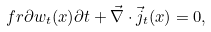Convert formula to latex. <formula><loc_0><loc_0><loc_500><loc_500>\ f r { \partial w _ { t } ( x ) } { \partial t } + \vec { \nabla } \cdot \vec { j } _ { t } ( x ) = 0 ,</formula> 